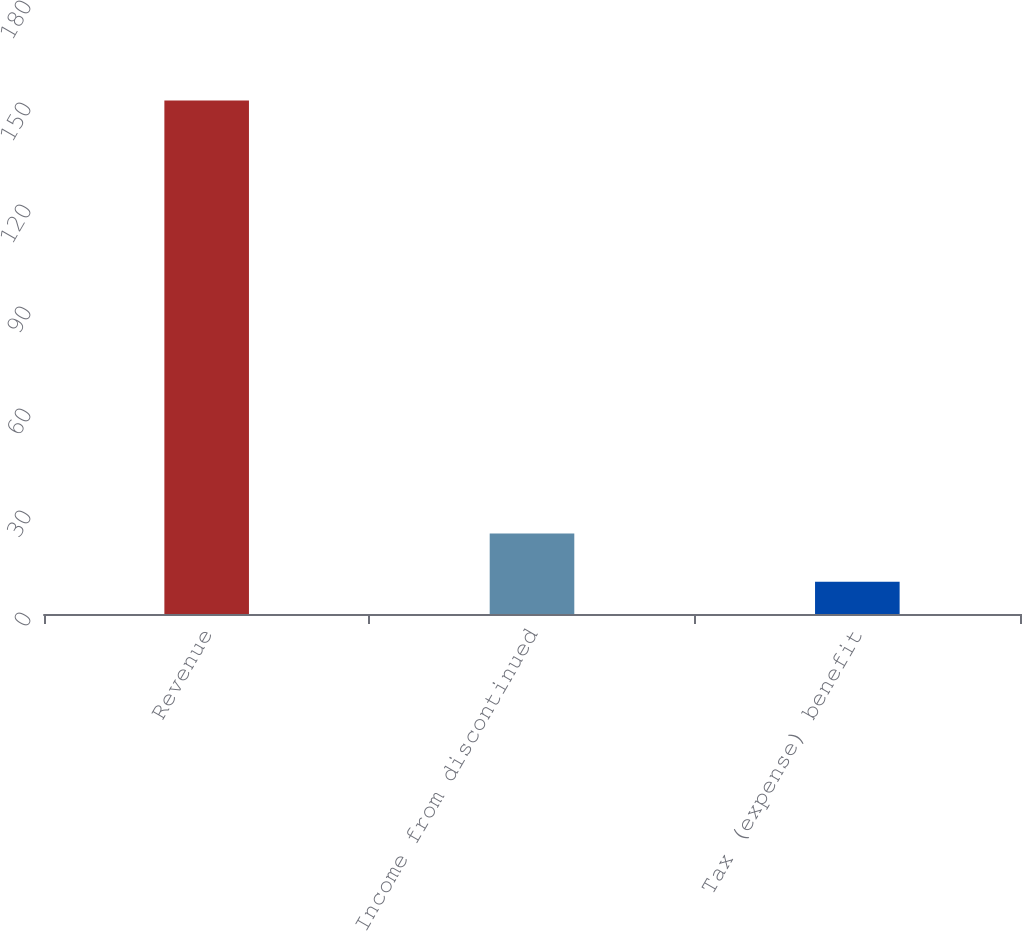<chart> <loc_0><loc_0><loc_500><loc_500><bar_chart><fcel>Revenue<fcel>Income from discontinued<fcel>Tax (expense) benefit<nl><fcel>151<fcel>23.65<fcel>9.5<nl></chart> 